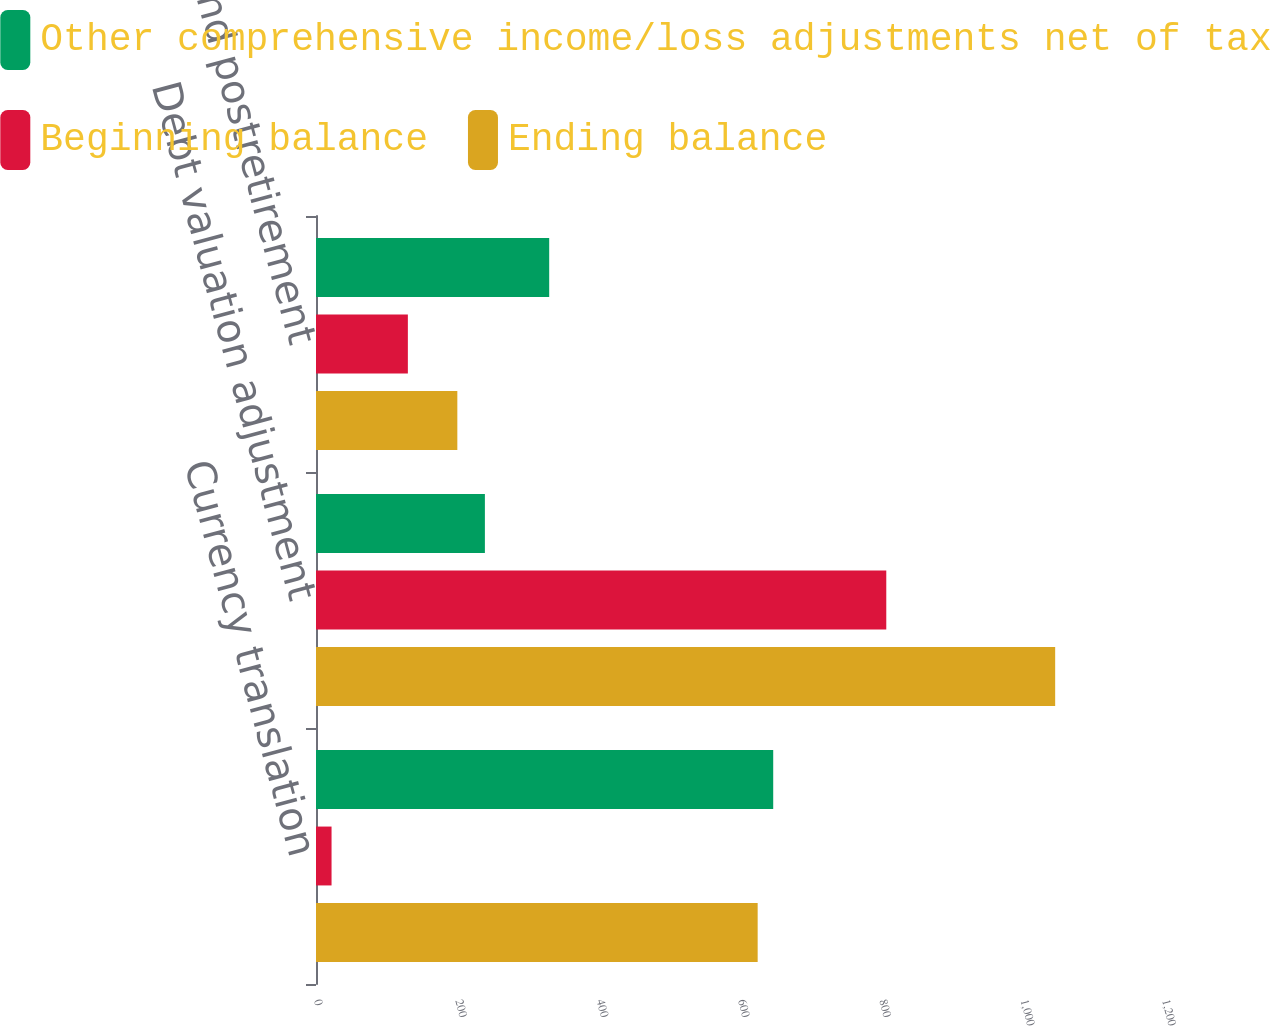<chart> <loc_0><loc_0><loc_500><loc_500><stacked_bar_chart><ecel><fcel>Currency translation<fcel>Debt valuation adjustment<fcel>Pension and postretirement<nl><fcel>Other comprehensive income/loss adjustments net of tax<fcel>647<fcel>239<fcel>330<nl><fcel>Beginning balance<fcel>22<fcel>807<fcel>130<nl><fcel>Ending balance<fcel>625<fcel>1046<fcel>200<nl></chart> 